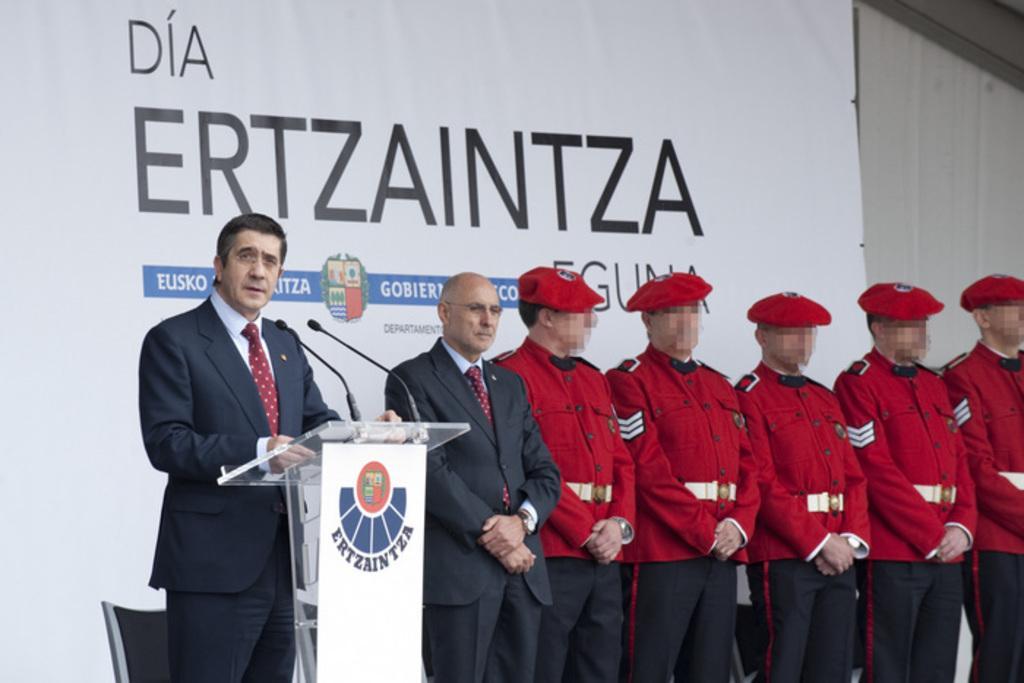What are the people in the image doing? The people in the image are standing in the center. What is in front of the people? There is a stand in front of the people. What is on the stand? There are microphones on the stand. What can be seen in the background of the image? There is a banner in the background of the image. What type of grain is being harvested by the beast in the image? There is no beast or grain present in the image; it features people standing with microphones on a stand. 